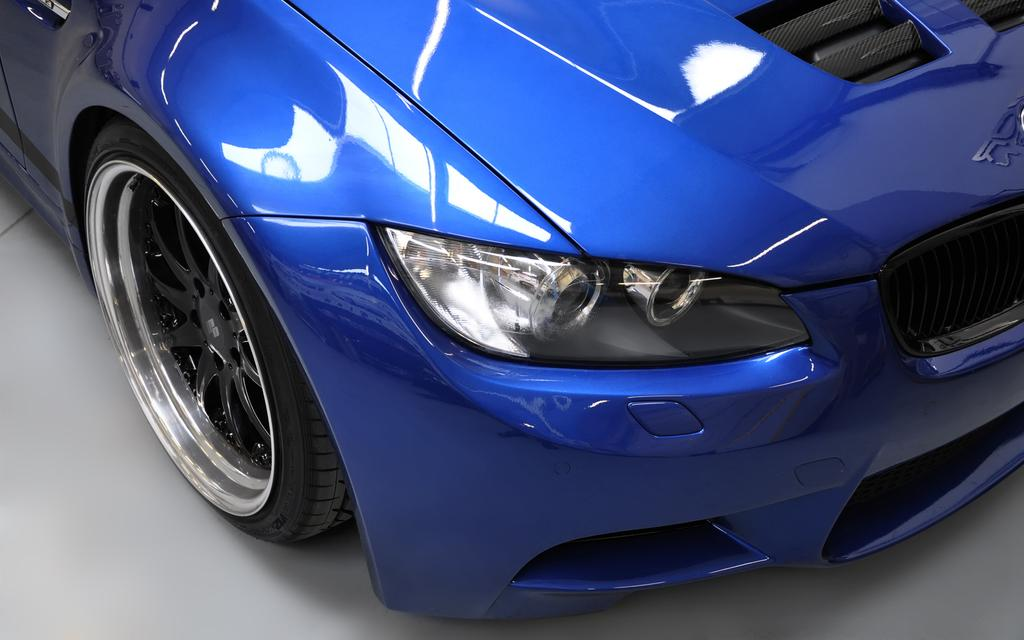What color is the car in the image? The car in the image is blue. Where is the car located in the image? The car is on the floor. What type of card is the car holding in the image? There is no card present in the image, as the car is an inanimate object and cannot hold cards. 